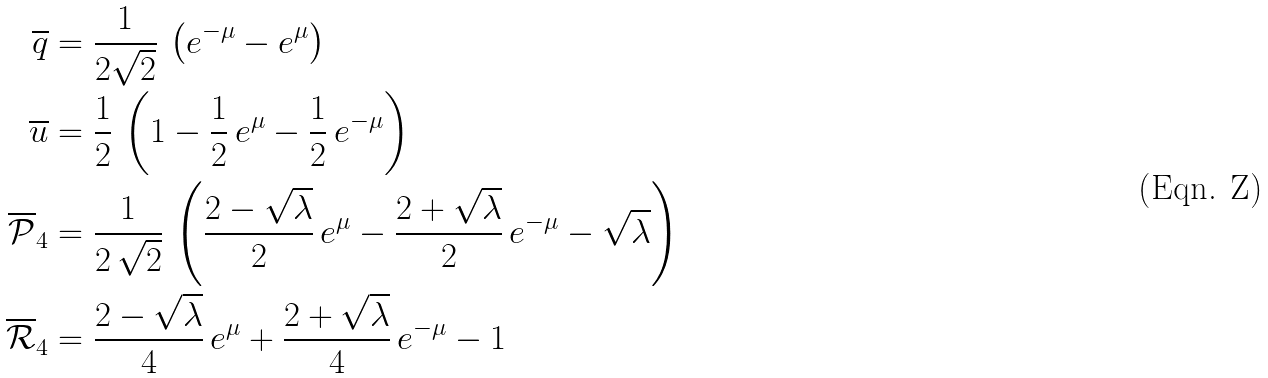Convert formula to latex. <formula><loc_0><loc_0><loc_500><loc_500>\overline { q } & = \frac { 1 } { 2 \sqrt { 2 } } \, \left ( e ^ { - \mu } - e ^ { \mu } \right ) \\ \overline { u } & = \frac { 1 } { 2 } \, \left ( 1 - \frac { 1 } { 2 } \, e ^ { \mu } - \frac { 1 } { 2 } \, e ^ { - \mu } \right ) \\ \overline { \mathcal { P } } _ { 4 } & = \frac { 1 } { 2 \, \sqrt { 2 } } \, \left ( \frac { 2 - \sqrt { \lambda } } { 2 } \, e ^ { \mu } - \frac { 2 + \sqrt { \lambda } } { 2 } \, e ^ { - \mu } - \sqrt { \lambda } \right ) \\ \overline { \mathcal { R } } _ { 4 } & = \frac { 2 - \sqrt { \lambda } } { 4 } \, e ^ { \mu } + \frac { 2 + \sqrt { \lambda } } { 4 } \, e ^ { - \mu } - 1</formula> 